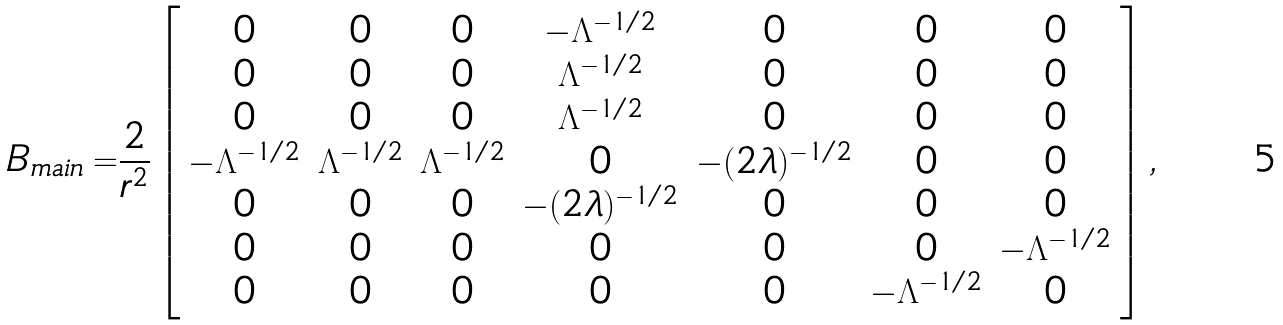Convert formula to latex. <formula><loc_0><loc_0><loc_500><loc_500>B _ { m a i n } = & \frac { 2 } { r ^ { 2 } } \left [ \begin{array} { c c c c c c c } 0 & 0 & 0 & - \Lambda ^ { - 1 / 2 } & 0 & 0 & 0 \\ 0 & 0 & 0 & \Lambda ^ { - 1 / 2 } & 0 & 0 & 0 \\ 0 & 0 & 0 & \Lambda ^ { - 1 / 2 } & 0 & 0 & 0 \\ - \Lambda ^ { - 1 / 2 } & \Lambda ^ { - 1 / 2 } & \Lambda ^ { - 1 / 2 } & 0 & - ( 2 \lambda ) ^ { - 1 / 2 } & 0 & 0 \\ 0 & 0 & 0 & - ( 2 \lambda ) ^ { - 1 / 2 } & 0 & 0 & 0 \\ 0 & 0 & 0 & 0 & 0 & 0 & - \Lambda ^ { - 1 / 2 } \\ 0 & 0 & 0 & 0 & 0 & - \Lambda ^ { - 1 / 2 } & 0 \end{array} \right ] ,</formula> 